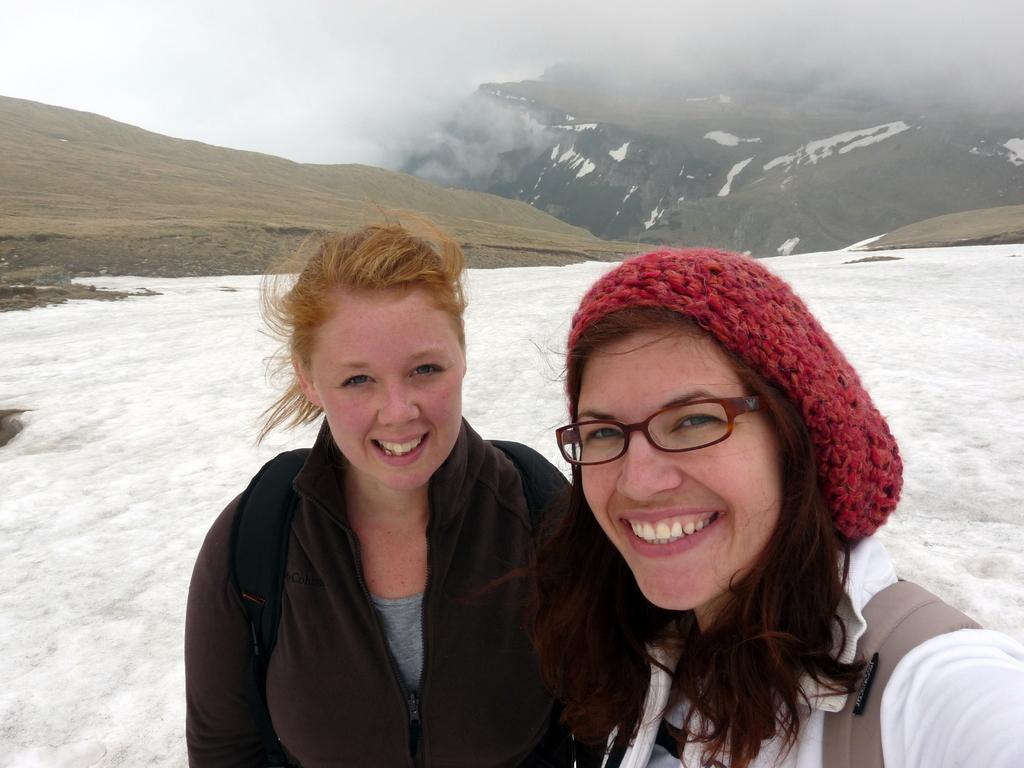Can you describe this image briefly? In this picture there are two girls in the center of the image and there is snow at the bottom side of the image and there are mountains at the top side of the image. 